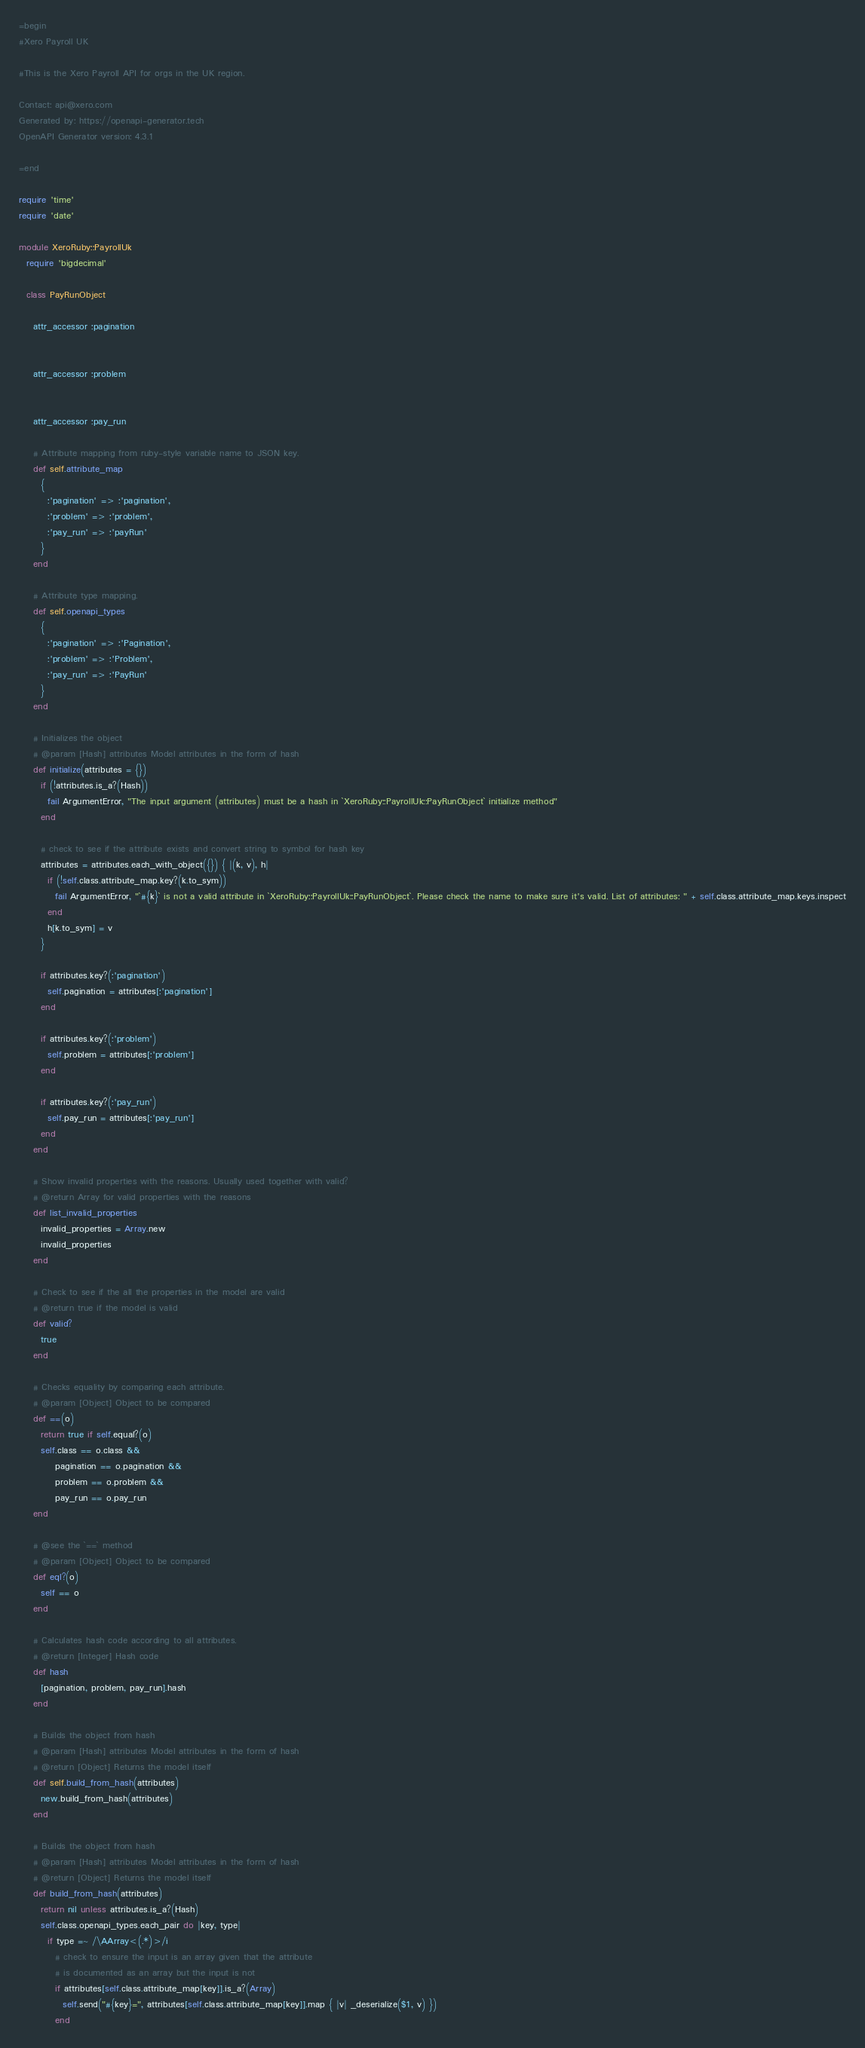Convert code to text. <code><loc_0><loc_0><loc_500><loc_500><_Ruby_>=begin
#Xero Payroll UK

#This is the Xero Payroll API for orgs in the UK region.

Contact: api@xero.com
Generated by: https://openapi-generator.tech
OpenAPI Generator version: 4.3.1

=end

require 'time'
require 'date'

module XeroRuby::PayrollUk
  require 'bigdecimal'

  class PayRunObject

    attr_accessor :pagination
    

    attr_accessor :problem
    

    attr_accessor :pay_run
    
    # Attribute mapping from ruby-style variable name to JSON key.
    def self.attribute_map
      {
        :'pagination' => :'pagination',
        :'problem' => :'problem',
        :'pay_run' => :'payRun'
      }
    end

    # Attribute type mapping.
    def self.openapi_types
      {
        :'pagination' => :'Pagination',
        :'problem' => :'Problem',
        :'pay_run' => :'PayRun'
      }
    end

    # Initializes the object
    # @param [Hash] attributes Model attributes in the form of hash
    def initialize(attributes = {})
      if (!attributes.is_a?(Hash))
        fail ArgumentError, "The input argument (attributes) must be a hash in `XeroRuby::PayrollUk::PayRunObject` initialize method"
      end

      # check to see if the attribute exists and convert string to symbol for hash key
      attributes = attributes.each_with_object({}) { |(k, v), h|
        if (!self.class.attribute_map.key?(k.to_sym))
          fail ArgumentError, "`#{k}` is not a valid attribute in `XeroRuby::PayrollUk::PayRunObject`. Please check the name to make sure it's valid. List of attributes: " + self.class.attribute_map.keys.inspect
        end
        h[k.to_sym] = v
      }

      if attributes.key?(:'pagination')
        self.pagination = attributes[:'pagination']
      end

      if attributes.key?(:'problem')
        self.problem = attributes[:'problem']
      end

      if attributes.key?(:'pay_run')
        self.pay_run = attributes[:'pay_run']
      end
    end

    # Show invalid properties with the reasons. Usually used together with valid?
    # @return Array for valid properties with the reasons
    def list_invalid_properties
      invalid_properties = Array.new
      invalid_properties
    end

    # Check to see if the all the properties in the model are valid
    # @return true if the model is valid
    def valid?
      true
    end

    # Checks equality by comparing each attribute.
    # @param [Object] Object to be compared
    def ==(o)
      return true if self.equal?(o)
      self.class == o.class &&
          pagination == o.pagination &&
          problem == o.problem &&
          pay_run == o.pay_run
    end

    # @see the `==` method
    # @param [Object] Object to be compared
    def eql?(o)
      self == o
    end

    # Calculates hash code according to all attributes.
    # @return [Integer] Hash code
    def hash
      [pagination, problem, pay_run].hash
    end

    # Builds the object from hash
    # @param [Hash] attributes Model attributes in the form of hash
    # @return [Object] Returns the model itself
    def self.build_from_hash(attributes)
      new.build_from_hash(attributes)
    end

    # Builds the object from hash
    # @param [Hash] attributes Model attributes in the form of hash
    # @return [Object] Returns the model itself
    def build_from_hash(attributes)
      return nil unless attributes.is_a?(Hash)
      self.class.openapi_types.each_pair do |key, type|
        if type =~ /\AArray<(.*)>/i
          # check to ensure the input is an array given that the attribute
          # is documented as an array but the input is not
          if attributes[self.class.attribute_map[key]].is_a?(Array)
            self.send("#{key}=", attributes[self.class.attribute_map[key]].map { |v| _deserialize($1, v) })
          end</code> 